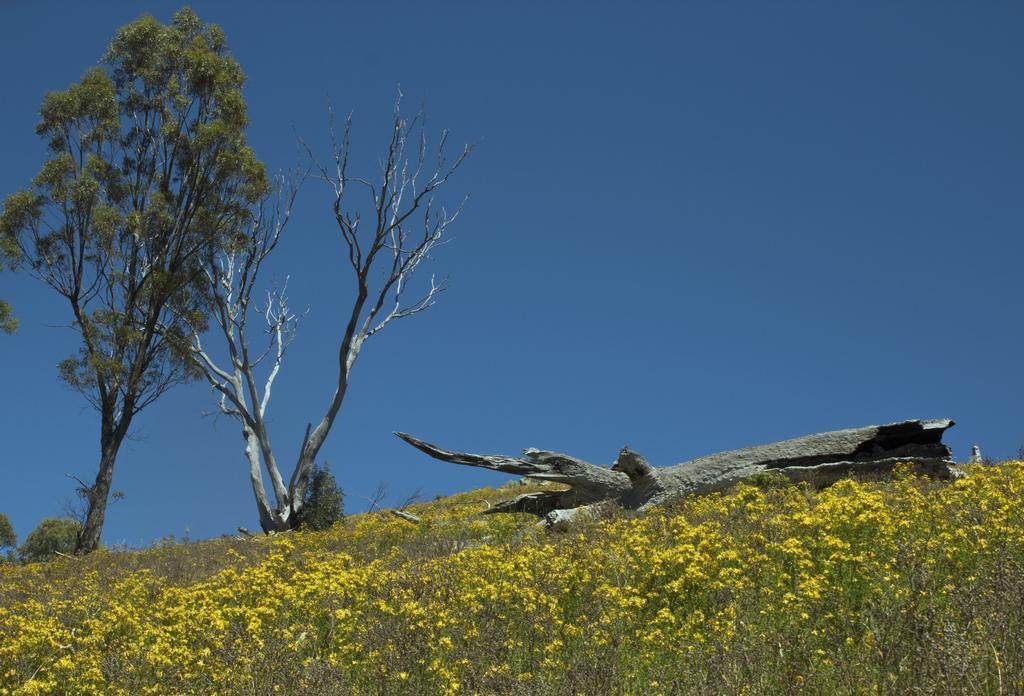Describe this image in one or two sentences. In this picture there are trees. At the bottom there are plants and flowers and there is a tree trunk. At the top there is sky. 